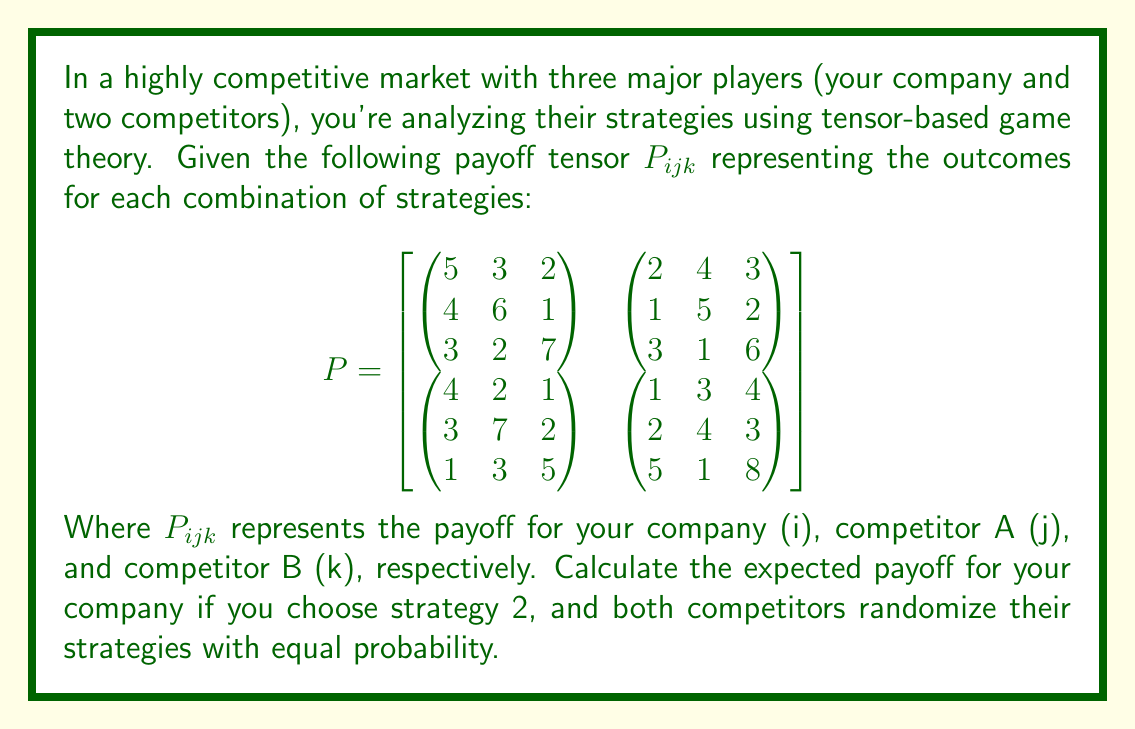Provide a solution to this math problem. To solve this problem, we'll follow these steps:

1) Identify the relevant slice of the payoff tensor:
   Since you're choosing strategy 2, we'll focus on the second "layer" of the tensor.

2) Extract the relevant payoff matrix:
   $$P_{2jk} = \begin{pmatrix}
   4 & 6 & 1 \\
   1 & 5 & 2 \\
   3 & 7 & 2 \\
   2 & 4 & 3
   \end{pmatrix}$$

3) Calculate the probability distribution for competitors' strategies:
   Both competitors randomize with equal probability, so each strategy has a probability of $\frac{1}{3}$.

4) Calculate the expected payoff:
   We'll sum all elements of $P_{2jk}$, each multiplied by the probability of that outcome occurring.

   $E = \frac{1}{9}(4 + 6 + 1 + 1 + 5 + 2 + 3 + 7 + 2 + 2 + 4 + 3)$

5) Simplify:
   $E = \frac{1}{9}(40) = \frac{40}{9}$

Therefore, the expected payoff for your company is $\frac{40}{9}$.
Answer: $\frac{40}{9}$ 